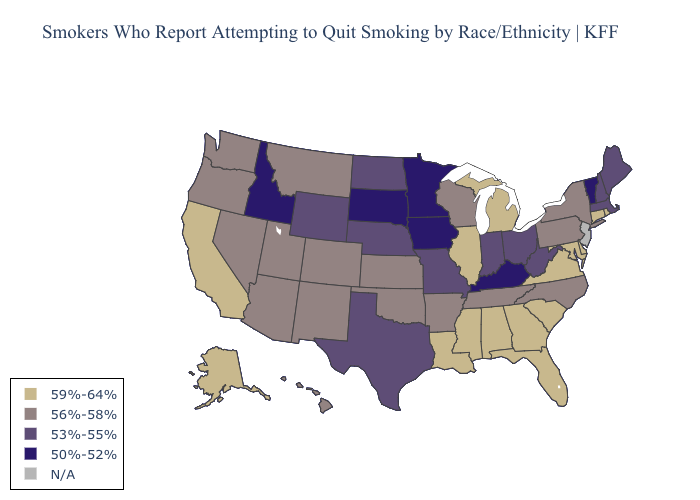What is the highest value in the Northeast ?
Quick response, please. 59%-64%. Among the states that border Washington , which have the lowest value?
Give a very brief answer. Idaho. Does Utah have the highest value in the USA?
Concise answer only. No. Which states have the lowest value in the South?
Be succinct. Kentucky. Which states have the lowest value in the USA?
Answer briefly. Idaho, Iowa, Kentucky, Minnesota, South Dakota, Vermont. What is the lowest value in states that border Florida?
Short answer required. 59%-64%. What is the lowest value in the Northeast?
Keep it brief. 50%-52%. What is the value of Montana?
Be succinct. 56%-58%. What is the highest value in the Northeast ?
Write a very short answer. 59%-64%. Which states have the lowest value in the USA?
Be succinct. Idaho, Iowa, Kentucky, Minnesota, South Dakota, Vermont. What is the value of Utah?
Keep it brief. 56%-58%. Name the states that have a value in the range 59%-64%?
Short answer required. Alabama, Alaska, California, Connecticut, Delaware, Florida, Georgia, Illinois, Louisiana, Maryland, Michigan, Mississippi, Rhode Island, South Carolina, Virginia. Name the states that have a value in the range 50%-52%?
Give a very brief answer. Idaho, Iowa, Kentucky, Minnesota, South Dakota, Vermont. Name the states that have a value in the range 59%-64%?
Give a very brief answer. Alabama, Alaska, California, Connecticut, Delaware, Florida, Georgia, Illinois, Louisiana, Maryland, Michigan, Mississippi, Rhode Island, South Carolina, Virginia. 